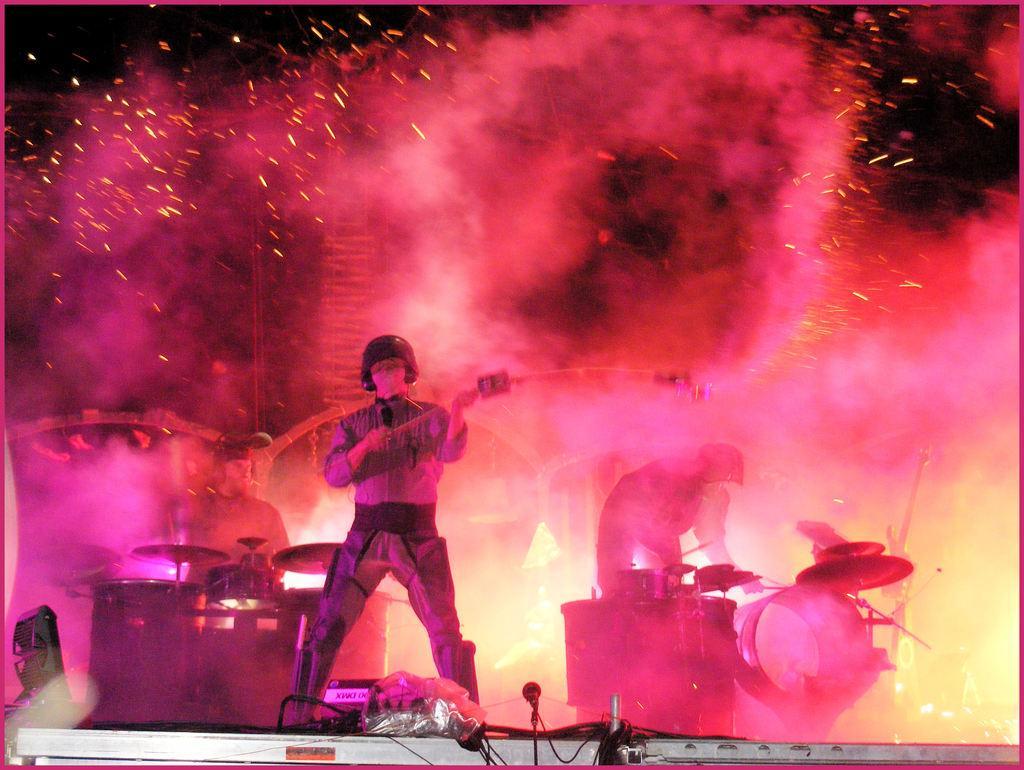Could you give a brief overview of what you see in this image? In the picture I can see a person wearing helmet is holding an object in his hands and there are two persons playing musical instruments in the background. 